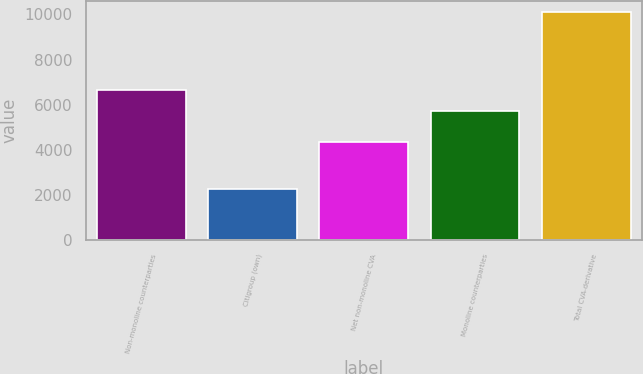Convert chart to OTSL. <chart><loc_0><loc_0><loc_500><loc_500><bar_chart><fcel>Non-monoline counterparties<fcel>Citigroup (own)<fcel>Net non-monoline CVA<fcel>Monoline counterparties<fcel>Total CVA-derivative<nl><fcel>6653<fcel>2282<fcel>4371<fcel>5736<fcel>10107<nl></chart> 